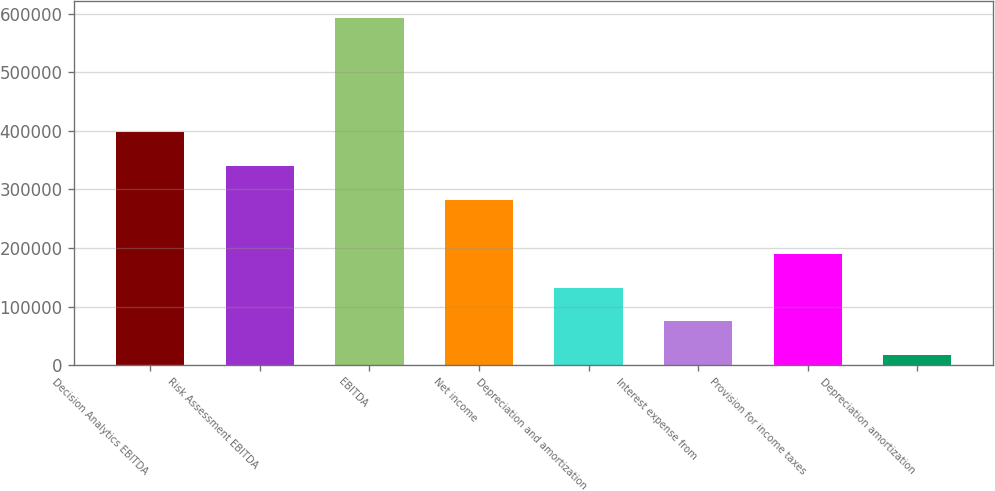<chart> <loc_0><loc_0><loc_500><loc_500><bar_chart><fcel>Decision Analytics EBITDA<fcel>Risk Assessment EBITDA<fcel>EBITDA<fcel>Net income<fcel>Depreciation and amortization<fcel>Interest expense from<fcel>Provision for income taxes<fcel>Depreciation amortization<nl><fcel>397851<fcel>340304<fcel>592887<fcel>282758<fcel>132516<fcel>74969.4<fcel>190062<fcel>17423<nl></chart> 